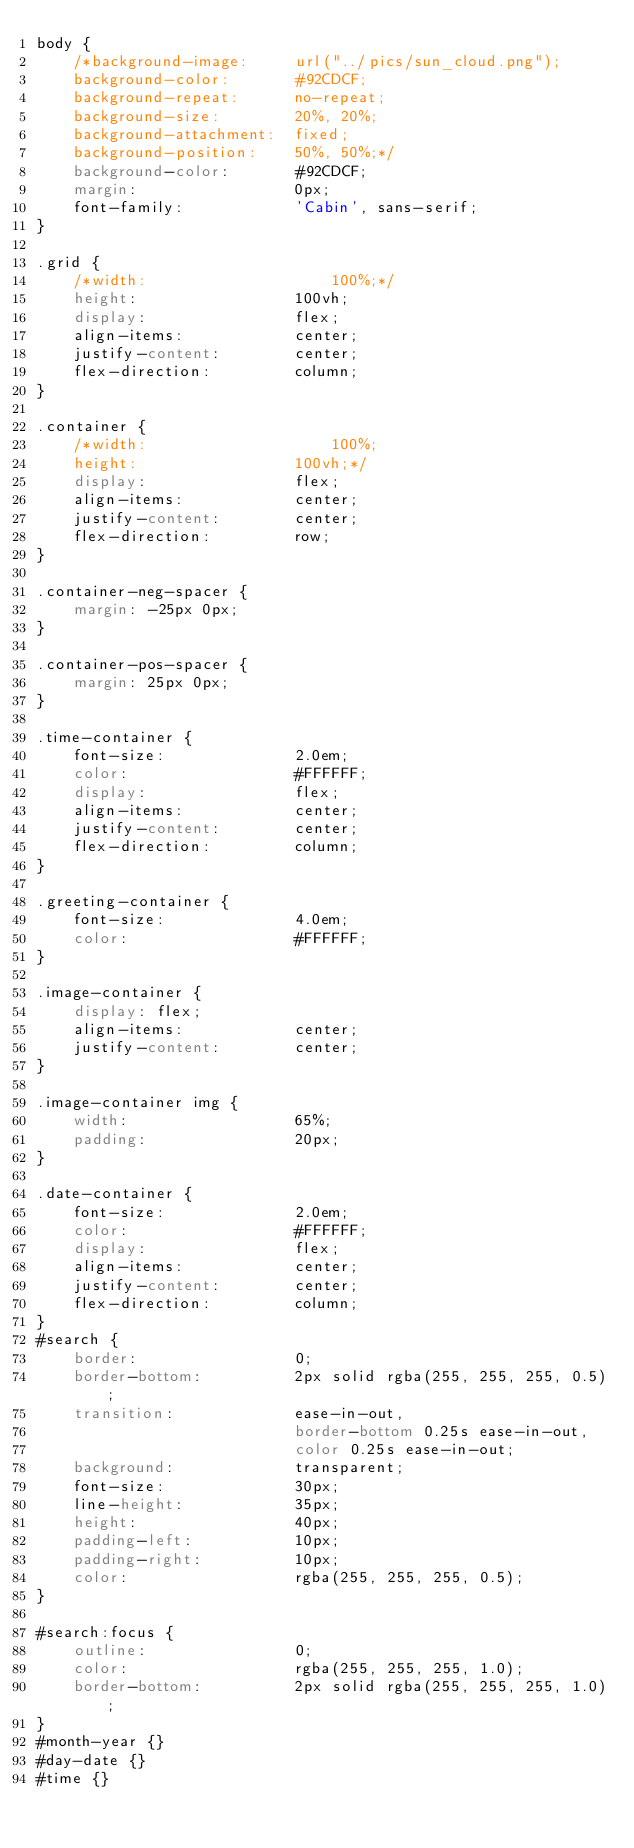<code> <loc_0><loc_0><loc_500><loc_500><_CSS_>body {
	/*background-image:		url("../pics/sun_cloud.png");
	background-color:		#92CDCF;
	background-repeat:		no-repeat;
	background-size:		20%, 20%;
	background-attachment:	fixed;
	background-position:	50%, 50%;*/
	background-color:		#92CDCF;
	margin:					0px;
	font-family:			'Cabin', sans-serif;
}

.grid {
	/*width:					100%;*/
    height:					100vh;
    display:				flex;
    align-items:			center;
    justify-content:		center;
    flex-direction:			column;
}

.container {
	/*width:					100%;
    height:					100vh;*/
    display:				flex;
    align-items:			center;
    justify-content:		center;
    flex-direction:			row;
}

.container-neg-spacer {
	margin: -25px 0px;
}

.container-pos-spacer {
	margin: 25px 0px;
}

.time-container {
	font-size:				2.0em;
	color:					#FFFFFF;
	display:				flex;
    align-items:			center;
    justify-content:		center;
    flex-direction:			column;
}

.greeting-container {
	font-size:				4.0em;
	color:					#FFFFFF;
}

.image-container {
	display: flex;
	align-items:			center;
    justify-content:		center;
}

.image-container img {
	width:					65%;
	padding:				20px;
}

.date-container {
	font-size:				2.0em;
	color:					#FFFFFF;
	display:				flex;
    align-items:			center;
    justify-content:		center;
    flex-direction:			column;
}
#search {
	border:					0;
	border-bottom:			2px solid rgba(255, 255, 255, 0.5);
	transition:				ease-in-out,
							border-bottom 0.25s ease-in-out,
							color 0.25s ease-in-out;
	background:				transparent;
	font-size:				30px;
	line-height:			35px;
	height: 				40px;
	padding-left:			10px;
	padding-right:			10px;
	color:					rgba(255, 255, 255, 0.5);
}

#search:focus {
	outline:				0;
	color:					rgba(255, 255, 255, 1.0);
	border-bottom:			2px solid rgba(255, 255, 255, 1.0);
}
#month-year {}
#day-date {}
#time {}

</code> 